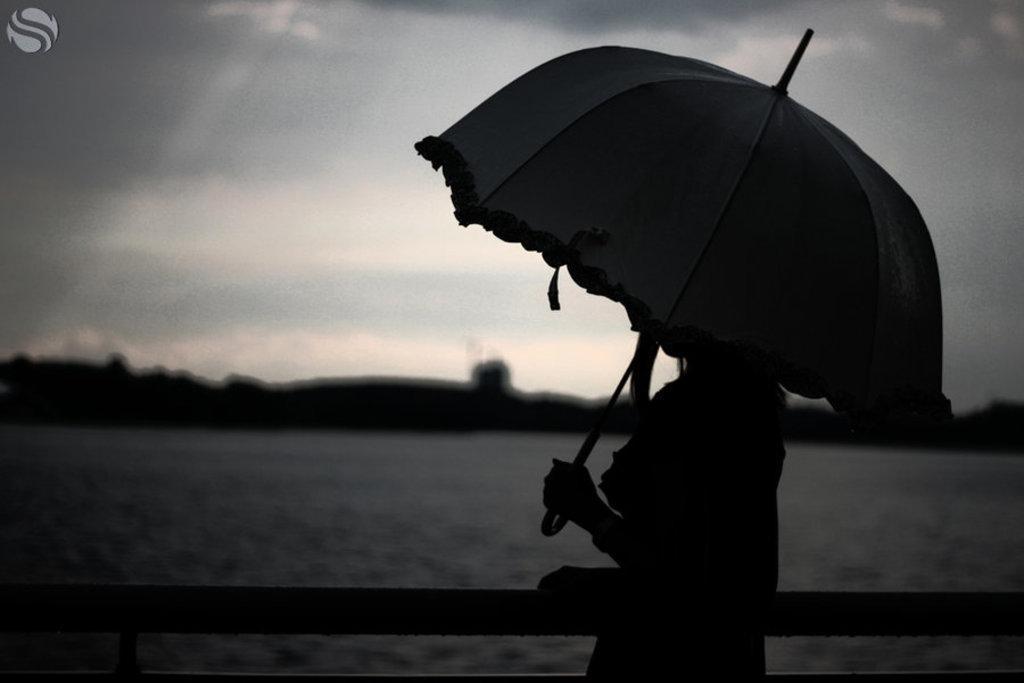In one or two sentences, can you explain what this image depicts? In this image I can see the person holding an umbrella. In the background I can see the water and the image is in black and white. 